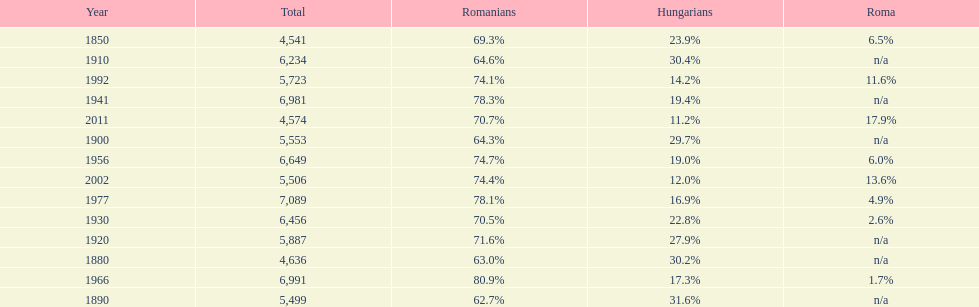What is the number of hungarians in 1850? 23.9%. 